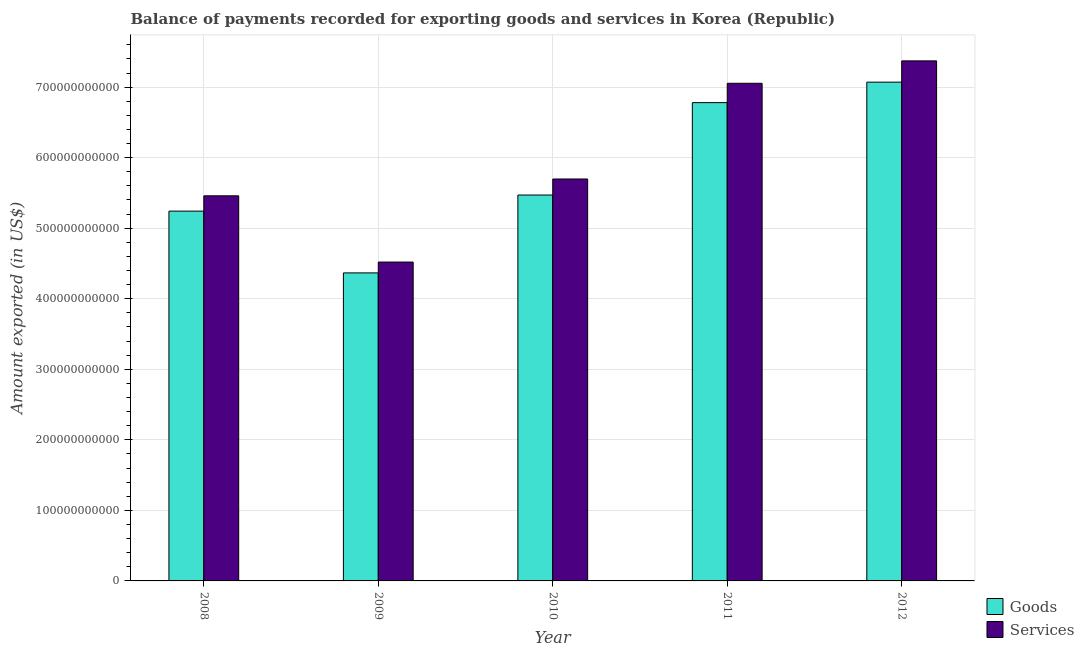How many different coloured bars are there?
Give a very brief answer. 2. Are the number of bars on each tick of the X-axis equal?
Give a very brief answer. Yes. How many bars are there on the 4th tick from the left?
Make the answer very short. 2. How many bars are there on the 3rd tick from the right?
Provide a succinct answer. 2. In how many cases, is the number of bars for a given year not equal to the number of legend labels?
Offer a terse response. 0. What is the amount of goods exported in 2010?
Give a very brief answer. 5.47e+11. Across all years, what is the maximum amount of goods exported?
Provide a short and direct response. 7.07e+11. Across all years, what is the minimum amount of goods exported?
Offer a very short reply. 4.37e+11. In which year was the amount of goods exported minimum?
Give a very brief answer. 2009. What is the total amount of goods exported in the graph?
Give a very brief answer. 2.89e+12. What is the difference between the amount of goods exported in 2008 and that in 2012?
Ensure brevity in your answer.  -1.83e+11. What is the difference between the amount of services exported in 2012 and the amount of goods exported in 2011?
Your answer should be compact. 3.18e+1. What is the average amount of services exported per year?
Your answer should be compact. 6.02e+11. In the year 2012, what is the difference between the amount of services exported and amount of goods exported?
Keep it short and to the point. 0. What is the ratio of the amount of services exported in 2008 to that in 2009?
Your answer should be very brief. 1.21. Is the amount of goods exported in 2008 less than that in 2010?
Provide a short and direct response. Yes. What is the difference between the highest and the second highest amount of goods exported?
Your answer should be compact. 2.90e+1. What is the difference between the highest and the lowest amount of goods exported?
Ensure brevity in your answer.  2.70e+11. Is the sum of the amount of services exported in 2008 and 2010 greater than the maximum amount of goods exported across all years?
Offer a very short reply. Yes. What does the 2nd bar from the left in 2008 represents?
Your answer should be compact. Services. What does the 1st bar from the right in 2008 represents?
Your answer should be compact. Services. How many bars are there?
Your response must be concise. 10. What is the difference between two consecutive major ticks on the Y-axis?
Offer a terse response. 1.00e+11. How many legend labels are there?
Provide a succinct answer. 2. How are the legend labels stacked?
Offer a very short reply. Vertical. What is the title of the graph?
Your answer should be compact. Balance of payments recorded for exporting goods and services in Korea (Republic). What is the label or title of the Y-axis?
Provide a succinct answer. Amount exported (in US$). What is the Amount exported (in US$) in Goods in 2008?
Keep it short and to the point. 5.24e+11. What is the Amount exported (in US$) of Services in 2008?
Ensure brevity in your answer.  5.46e+11. What is the Amount exported (in US$) of Goods in 2009?
Provide a short and direct response. 4.37e+11. What is the Amount exported (in US$) of Services in 2009?
Your response must be concise. 4.52e+11. What is the Amount exported (in US$) in Goods in 2010?
Your response must be concise. 5.47e+11. What is the Amount exported (in US$) in Services in 2010?
Make the answer very short. 5.70e+11. What is the Amount exported (in US$) of Goods in 2011?
Offer a terse response. 6.78e+11. What is the Amount exported (in US$) of Services in 2011?
Your response must be concise. 7.05e+11. What is the Amount exported (in US$) of Goods in 2012?
Your answer should be compact. 7.07e+11. What is the Amount exported (in US$) in Services in 2012?
Keep it short and to the point. 7.37e+11. Across all years, what is the maximum Amount exported (in US$) of Goods?
Provide a succinct answer. 7.07e+11. Across all years, what is the maximum Amount exported (in US$) in Services?
Provide a short and direct response. 7.37e+11. Across all years, what is the minimum Amount exported (in US$) in Goods?
Make the answer very short. 4.37e+11. Across all years, what is the minimum Amount exported (in US$) in Services?
Offer a terse response. 4.52e+11. What is the total Amount exported (in US$) in Goods in the graph?
Ensure brevity in your answer.  2.89e+12. What is the total Amount exported (in US$) of Services in the graph?
Give a very brief answer. 3.01e+12. What is the difference between the Amount exported (in US$) of Goods in 2008 and that in 2009?
Ensure brevity in your answer.  8.76e+1. What is the difference between the Amount exported (in US$) of Services in 2008 and that in 2009?
Make the answer very short. 9.39e+1. What is the difference between the Amount exported (in US$) of Goods in 2008 and that in 2010?
Provide a succinct answer. -2.28e+1. What is the difference between the Amount exported (in US$) in Services in 2008 and that in 2010?
Your answer should be compact. -2.39e+1. What is the difference between the Amount exported (in US$) of Goods in 2008 and that in 2011?
Your answer should be very brief. -1.54e+11. What is the difference between the Amount exported (in US$) of Services in 2008 and that in 2011?
Offer a terse response. -1.60e+11. What is the difference between the Amount exported (in US$) of Goods in 2008 and that in 2012?
Give a very brief answer. -1.83e+11. What is the difference between the Amount exported (in US$) in Services in 2008 and that in 2012?
Ensure brevity in your answer.  -1.91e+11. What is the difference between the Amount exported (in US$) of Goods in 2009 and that in 2010?
Provide a short and direct response. -1.10e+11. What is the difference between the Amount exported (in US$) in Services in 2009 and that in 2010?
Provide a succinct answer. -1.18e+11. What is the difference between the Amount exported (in US$) of Goods in 2009 and that in 2011?
Keep it short and to the point. -2.41e+11. What is the difference between the Amount exported (in US$) in Services in 2009 and that in 2011?
Your answer should be compact. -2.53e+11. What is the difference between the Amount exported (in US$) in Goods in 2009 and that in 2012?
Your answer should be very brief. -2.70e+11. What is the difference between the Amount exported (in US$) in Services in 2009 and that in 2012?
Give a very brief answer. -2.85e+11. What is the difference between the Amount exported (in US$) of Goods in 2010 and that in 2011?
Your answer should be very brief. -1.31e+11. What is the difference between the Amount exported (in US$) of Services in 2010 and that in 2011?
Provide a succinct answer. -1.36e+11. What is the difference between the Amount exported (in US$) in Goods in 2010 and that in 2012?
Provide a short and direct response. -1.60e+11. What is the difference between the Amount exported (in US$) of Services in 2010 and that in 2012?
Ensure brevity in your answer.  -1.67e+11. What is the difference between the Amount exported (in US$) of Goods in 2011 and that in 2012?
Keep it short and to the point. -2.90e+1. What is the difference between the Amount exported (in US$) of Services in 2011 and that in 2012?
Your answer should be very brief. -3.18e+1. What is the difference between the Amount exported (in US$) in Goods in 2008 and the Amount exported (in US$) in Services in 2009?
Give a very brief answer. 7.22e+1. What is the difference between the Amount exported (in US$) of Goods in 2008 and the Amount exported (in US$) of Services in 2010?
Provide a succinct answer. -4.55e+1. What is the difference between the Amount exported (in US$) of Goods in 2008 and the Amount exported (in US$) of Services in 2011?
Your response must be concise. -1.81e+11. What is the difference between the Amount exported (in US$) in Goods in 2008 and the Amount exported (in US$) in Services in 2012?
Make the answer very short. -2.13e+11. What is the difference between the Amount exported (in US$) in Goods in 2009 and the Amount exported (in US$) in Services in 2010?
Provide a succinct answer. -1.33e+11. What is the difference between the Amount exported (in US$) of Goods in 2009 and the Amount exported (in US$) of Services in 2011?
Offer a very short reply. -2.69e+11. What is the difference between the Amount exported (in US$) in Goods in 2009 and the Amount exported (in US$) in Services in 2012?
Offer a very short reply. -3.01e+11. What is the difference between the Amount exported (in US$) in Goods in 2010 and the Amount exported (in US$) in Services in 2011?
Provide a short and direct response. -1.58e+11. What is the difference between the Amount exported (in US$) in Goods in 2010 and the Amount exported (in US$) in Services in 2012?
Your answer should be very brief. -1.90e+11. What is the difference between the Amount exported (in US$) of Goods in 2011 and the Amount exported (in US$) of Services in 2012?
Provide a short and direct response. -5.92e+1. What is the average Amount exported (in US$) of Goods per year?
Provide a short and direct response. 5.79e+11. What is the average Amount exported (in US$) of Services per year?
Make the answer very short. 6.02e+11. In the year 2008, what is the difference between the Amount exported (in US$) in Goods and Amount exported (in US$) in Services?
Provide a short and direct response. -2.17e+1. In the year 2009, what is the difference between the Amount exported (in US$) of Goods and Amount exported (in US$) of Services?
Provide a short and direct response. -1.54e+1. In the year 2010, what is the difference between the Amount exported (in US$) in Goods and Amount exported (in US$) in Services?
Offer a terse response. -2.27e+1. In the year 2011, what is the difference between the Amount exported (in US$) of Goods and Amount exported (in US$) of Services?
Give a very brief answer. -2.74e+1. In the year 2012, what is the difference between the Amount exported (in US$) in Goods and Amount exported (in US$) in Services?
Offer a very short reply. -3.02e+1. What is the ratio of the Amount exported (in US$) in Goods in 2008 to that in 2009?
Keep it short and to the point. 1.2. What is the ratio of the Amount exported (in US$) in Services in 2008 to that in 2009?
Offer a very short reply. 1.21. What is the ratio of the Amount exported (in US$) of Goods in 2008 to that in 2010?
Provide a succinct answer. 0.96. What is the ratio of the Amount exported (in US$) of Services in 2008 to that in 2010?
Offer a terse response. 0.96. What is the ratio of the Amount exported (in US$) in Goods in 2008 to that in 2011?
Make the answer very short. 0.77. What is the ratio of the Amount exported (in US$) in Services in 2008 to that in 2011?
Your response must be concise. 0.77. What is the ratio of the Amount exported (in US$) in Goods in 2008 to that in 2012?
Offer a terse response. 0.74. What is the ratio of the Amount exported (in US$) in Services in 2008 to that in 2012?
Give a very brief answer. 0.74. What is the ratio of the Amount exported (in US$) of Goods in 2009 to that in 2010?
Ensure brevity in your answer.  0.8. What is the ratio of the Amount exported (in US$) in Services in 2009 to that in 2010?
Ensure brevity in your answer.  0.79. What is the ratio of the Amount exported (in US$) in Goods in 2009 to that in 2011?
Ensure brevity in your answer.  0.64. What is the ratio of the Amount exported (in US$) of Services in 2009 to that in 2011?
Give a very brief answer. 0.64. What is the ratio of the Amount exported (in US$) in Goods in 2009 to that in 2012?
Provide a succinct answer. 0.62. What is the ratio of the Amount exported (in US$) in Services in 2009 to that in 2012?
Provide a short and direct response. 0.61. What is the ratio of the Amount exported (in US$) in Goods in 2010 to that in 2011?
Make the answer very short. 0.81. What is the ratio of the Amount exported (in US$) of Services in 2010 to that in 2011?
Make the answer very short. 0.81. What is the ratio of the Amount exported (in US$) in Goods in 2010 to that in 2012?
Make the answer very short. 0.77. What is the ratio of the Amount exported (in US$) in Services in 2010 to that in 2012?
Offer a very short reply. 0.77. What is the ratio of the Amount exported (in US$) in Goods in 2011 to that in 2012?
Your answer should be compact. 0.96. What is the ratio of the Amount exported (in US$) of Services in 2011 to that in 2012?
Your response must be concise. 0.96. What is the difference between the highest and the second highest Amount exported (in US$) in Goods?
Keep it short and to the point. 2.90e+1. What is the difference between the highest and the second highest Amount exported (in US$) of Services?
Provide a short and direct response. 3.18e+1. What is the difference between the highest and the lowest Amount exported (in US$) of Goods?
Make the answer very short. 2.70e+11. What is the difference between the highest and the lowest Amount exported (in US$) of Services?
Your response must be concise. 2.85e+11. 